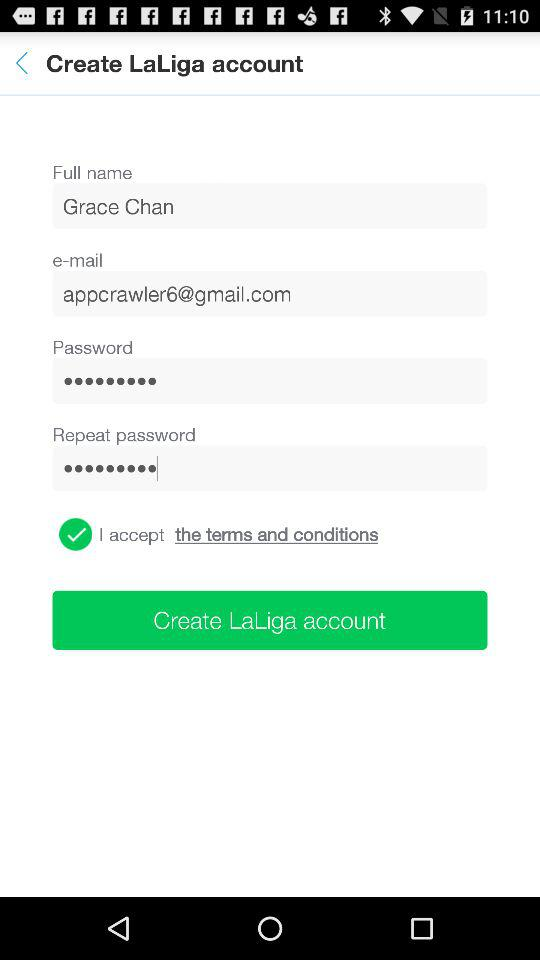What is the status of "I accept the terms and conditions"? The status is "on". 